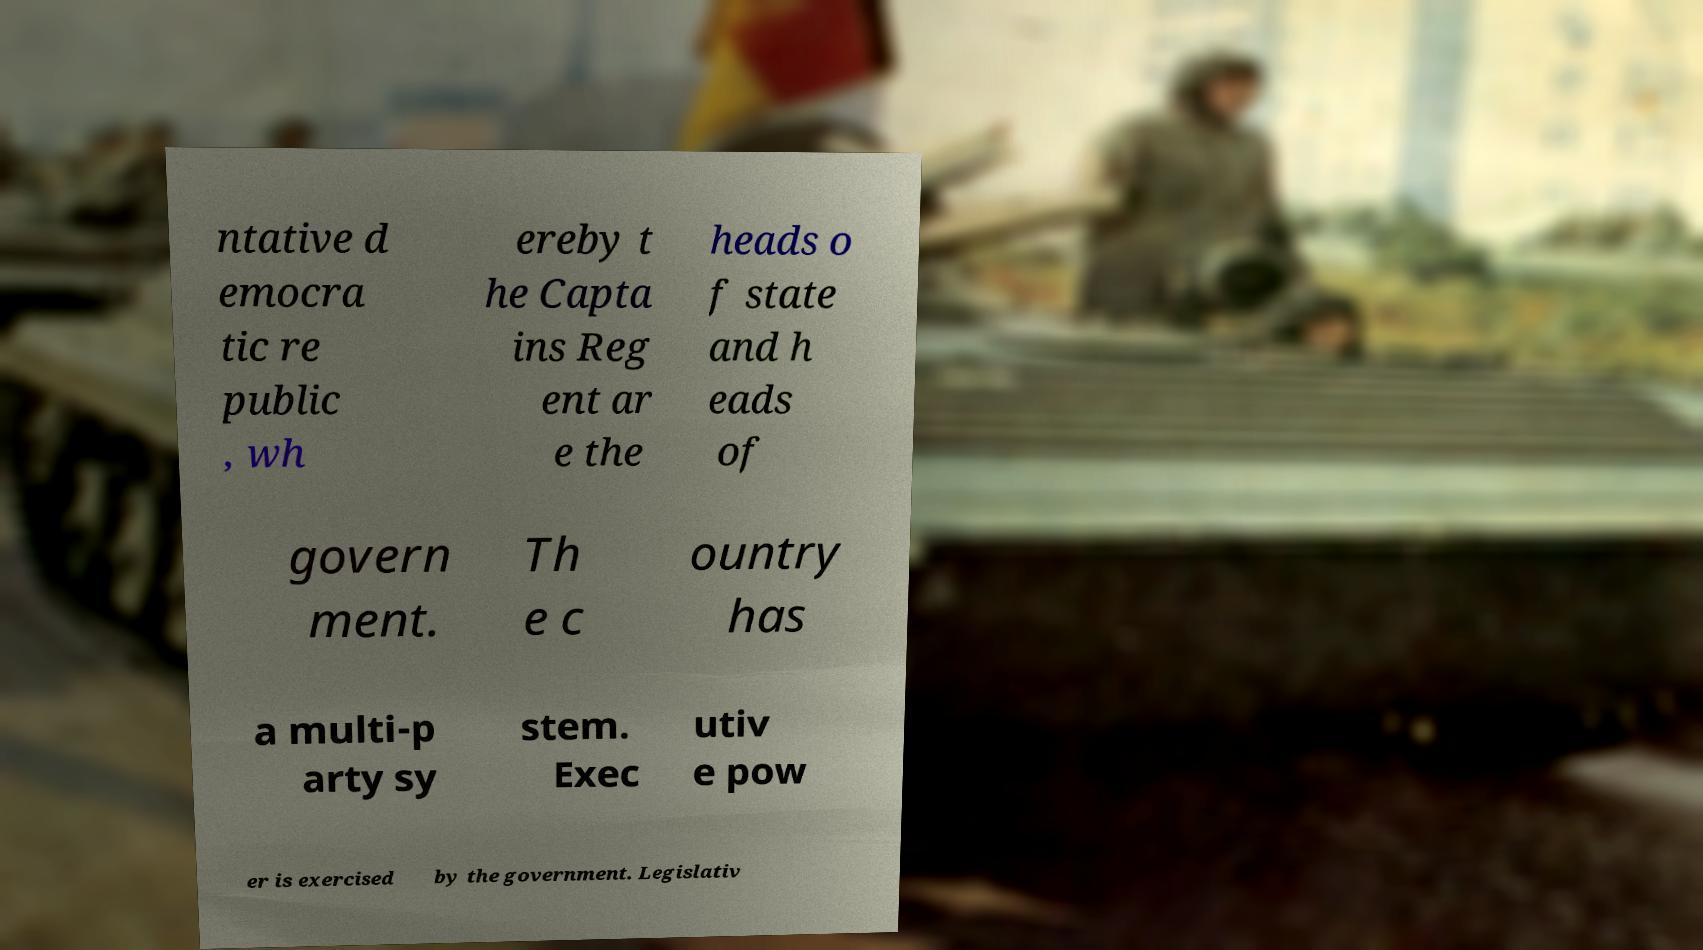Please read and relay the text visible in this image. What does it say? ntative d emocra tic re public , wh ereby t he Capta ins Reg ent ar e the heads o f state and h eads of govern ment. Th e c ountry has a multi-p arty sy stem. Exec utiv e pow er is exercised by the government. Legislativ 